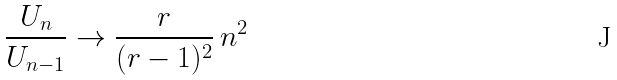<formula> <loc_0><loc_0><loc_500><loc_500>\frac { U _ { n } } { U _ { n - 1 } } \to \frac { r } { ( r - 1 ) ^ { 2 } } \, n ^ { 2 }</formula> 